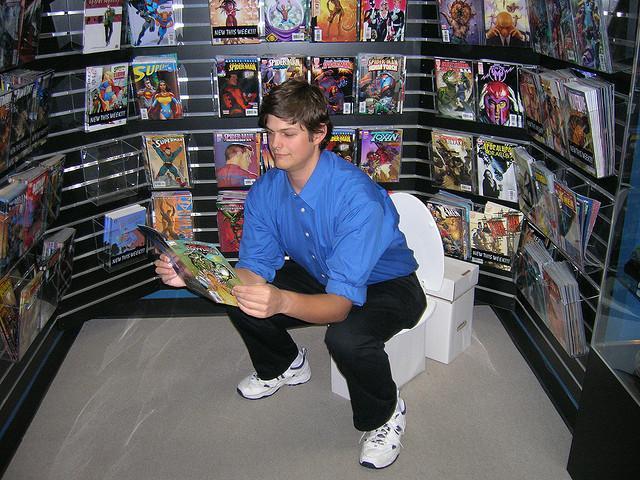How many books are there?
Give a very brief answer. 9. 